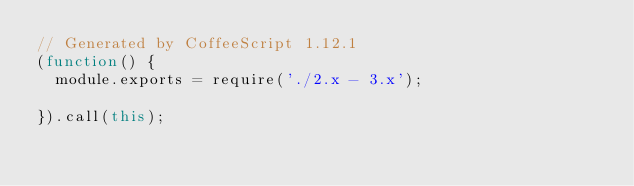Convert code to text. <code><loc_0><loc_0><loc_500><loc_500><_JavaScript_>// Generated by CoffeeScript 1.12.1
(function() {
  module.exports = require('./2.x - 3.x');

}).call(this);
</code> 